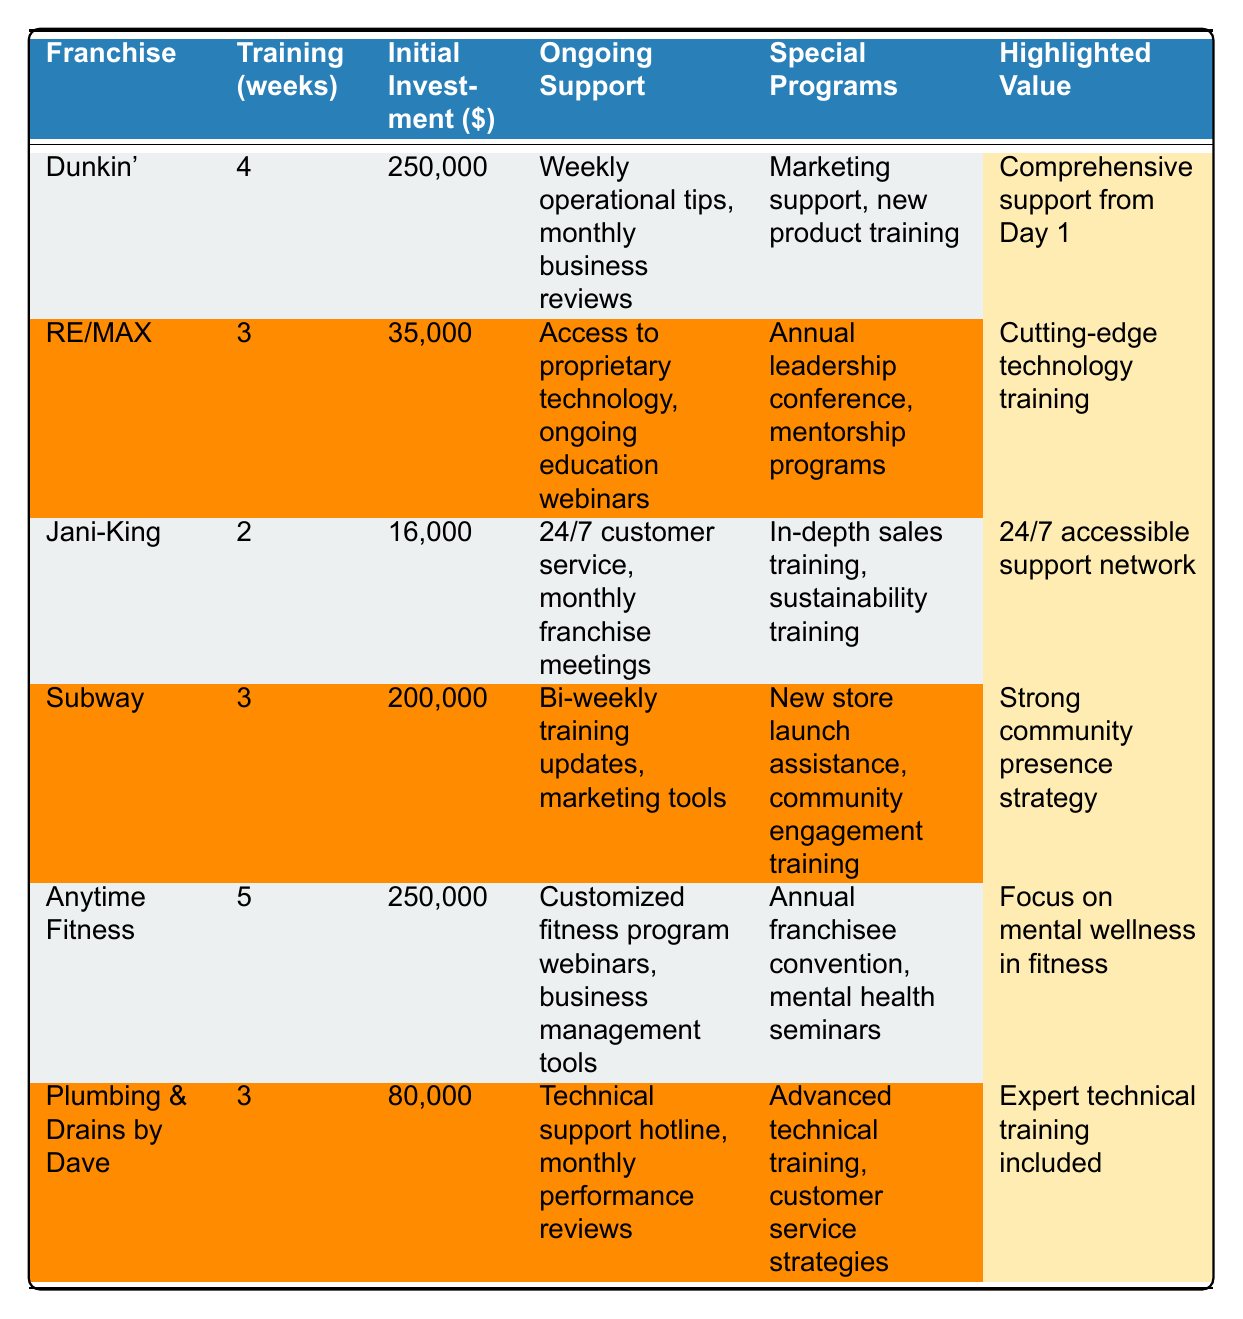What is the training duration for Dunkin'? The table shows that Dunkin' has a training duration of 4 weeks.
Answer: 4 weeks Which franchise requires the highest initial investment? Looking through the initial investment column, Dunkin' and Anytime Fitness both require $250,000, which is the highest amount.
Answer: Dunkin' and Anytime Fitness ($250,000) Does Jani-King offer any special programs? Yes, the table indicates that Jani-King offers in-depth sales training and sustainability training as special programs.
Answer: Yes How many weeks of training does Anytime Fitness provide? The table lists the training duration for Anytime Fitness as 5 weeks.
Answer: 5 weeks What is the ongoing support provided by RE/MAX? According to the table, RE/MAX offers access to proprietary technology and ongoing education webinars as ongoing support.
Answer: Access to proprietary technology and ongoing education webinars Which franchise offers a focus on mental wellness? Anytime Fitness highlights a focus on mental wellness in its training and support services.
Answer: Anytime Fitness What is the average initial investment of all franchises listed? Summing the initial investments (250,000 + 35,000 + 16,000 + 200,000 + 250,000 + 80,000 = 831,000) and dividing by the number of franchises (6) gives an average of 138,500.
Answer: 138,500 Is there any franchise that provides a technical support hotline? Yes, Plumbing & Drains by Dave offers a technical support hotline as part of its ongoing support.
Answer: Yes What is the highlighted value for Subway? The table shows that the highlighted value for Subway is "Strong community presence strategy."
Answer: Strong community presence strategy Which franchise has the shortest training duration, and what is it? Jani-King has the shortest training duration of 2 weeks, as indicated in the training duration column.
Answer: Jani-King, 2 weeks How many franchises offer special programs related to customer service? Both Jani-King and Plumbing & Drains by Dave provide special programs related to customer service (customer service strategies).
Answer: 2 franchises What is the difference in training weeks between Anytime Fitness and Jani-King? Anytime Fitness has 5 weeks and Jani-King has 2 weeks. The difference is 5 - 2, which equals 3 weeks.
Answer: 3 weeks Which franchises provide monthly reviews or meetings as part of ongoing support? Dunkin' and Jani-King both offer monthly business reviews or monthly franchise meetings as part of their ongoing support.
Answer: Dunkin' and Jani-King 